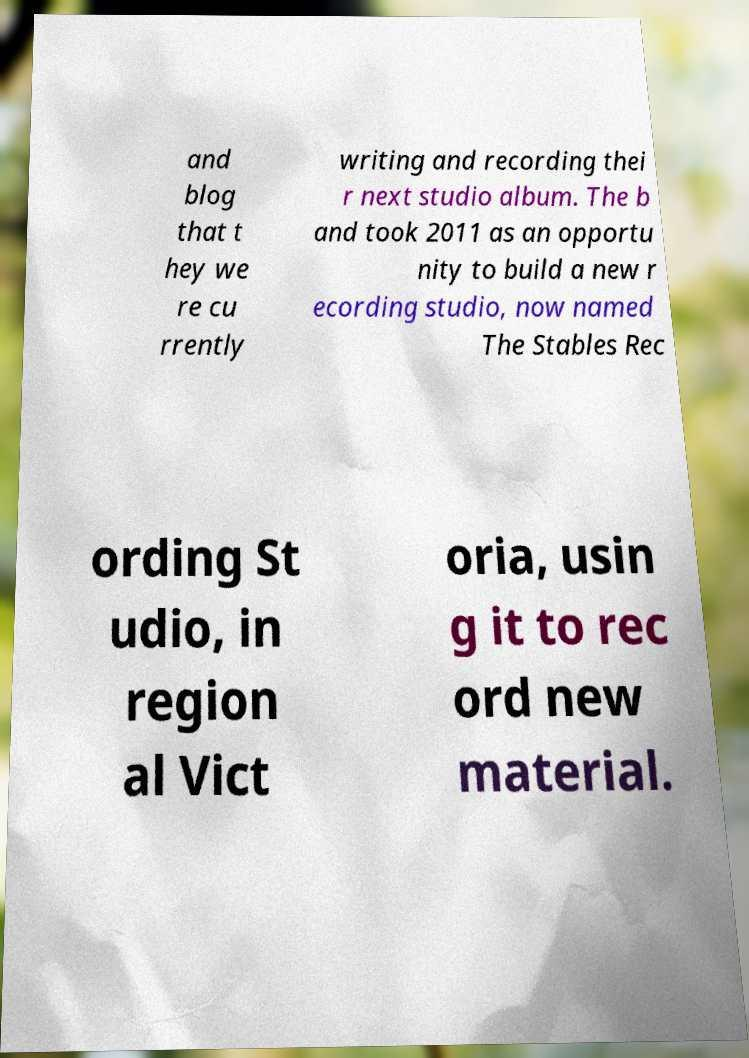Please identify and transcribe the text found in this image. and blog that t hey we re cu rrently writing and recording thei r next studio album. The b and took 2011 as an opportu nity to build a new r ecording studio, now named The Stables Rec ording St udio, in region al Vict oria, usin g it to rec ord new material. 